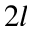<formula> <loc_0><loc_0><loc_500><loc_500>2 l</formula> 